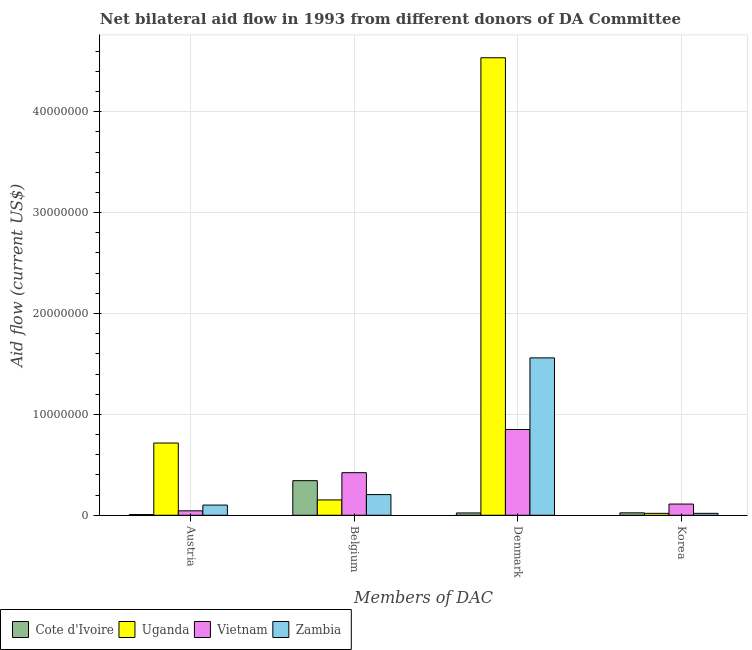How many different coloured bars are there?
Offer a very short reply. 4. Are the number of bars per tick equal to the number of legend labels?
Your answer should be very brief. Yes. How many bars are there on the 1st tick from the right?
Keep it short and to the point. 4. What is the label of the 4th group of bars from the left?
Your answer should be compact. Korea. What is the amount of aid given by denmark in Cote d'Ivoire?
Offer a very short reply. 2.30e+05. Across all countries, what is the maximum amount of aid given by denmark?
Keep it short and to the point. 4.54e+07. Across all countries, what is the minimum amount of aid given by belgium?
Provide a succinct answer. 1.52e+06. In which country was the amount of aid given by austria maximum?
Make the answer very short. Uganda. In which country was the amount of aid given by austria minimum?
Your answer should be compact. Cote d'Ivoire. What is the total amount of aid given by belgium in the graph?
Your answer should be very brief. 1.12e+07. What is the difference between the amount of aid given by korea in Cote d'Ivoire and that in Uganda?
Your response must be concise. 5.00e+04. What is the difference between the amount of aid given by denmark in Cote d'Ivoire and the amount of aid given by belgium in Vietnam?
Make the answer very short. -3.99e+06. What is the average amount of aid given by belgium per country?
Offer a very short reply. 2.80e+06. What is the difference between the amount of aid given by denmark and amount of aid given by korea in Zambia?
Your answer should be very brief. 1.54e+07. In how many countries, is the amount of aid given by austria greater than 14000000 US$?
Ensure brevity in your answer.  0. What is the ratio of the amount of aid given by korea in Cote d'Ivoire to that in Zambia?
Provide a succinct answer. 1.26. What is the difference between the highest and the second highest amount of aid given by austria?
Your response must be concise. 6.15e+06. What is the difference between the highest and the lowest amount of aid given by denmark?
Your answer should be compact. 4.51e+07. In how many countries, is the amount of aid given by austria greater than the average amount of aid given by austria taken over all countries?
Your answer should be very brief. 1. Is it the case that in every country, the sum of the amount of aid given by korea and amount of aid given by austria is greater than the sum of amount of aid given by belgium and amount of aid given by denmark?
Offer a very short reply. No. What does the 2nd bar from the left in Denmark represents?
Make the answer very short. Uganda. What does the 4th bar from the right in Denmark represents?
Keep it short and to the point. Cote d'Ivoire. Are all the bars in the graph horizontal?
Your response must be concise. No. How many countries are there in the graph?
Provide a short and direct response. 4. What is the difference between two consecutive major ticks on the Y-axis?
Keep it short and to the point. 1.00e+07. Does the graph contain grids?
Ensure brevity in your answer.  Yes. How are the legend labels stacked?
Make the answer very short. Horizontal. What is the title of the graph?
Ensure brevity in your answer.  Net bilateral aid flow in 1993 from different donors of DA Committee. What is the label or title of the X-axis?
Give a very brief answer. Members of DAC. What is the Aid flow (current US$) of Uganda in Austria?
Ensure brevity in your answer.  7.16e+06. What is the Aid flow (current US$) of Vietnam in Austria?
Your answer should be compact. 4.40e+05. What is the Aid flow (current US$) in Zambia in Austria?
Ensure brevity in your answer.  1.01e+06. What is the Aid flow (current US$) of Cote d'Ivoire in Belgium?
Make the answer very short. 3.43e+06. What is the Aid flow (current US$) in Uganda in Belgium?
Give a very brief answer. 1.52e+06. What is the Aid flow (current US$) of Vietnam in Belgium?
Provide a short and direct response. 4.22e+06. What is the Aid flow (current US$) in Zambia in Belgium?
Your answer should be compact. 2.05e+06. What is the Aid flow (current US$) in Cote d'Ivoire in Denmark?
Offer a terse response. 2.30e+05. What is the Aid flow (current US$) of Uganda in Denmark?
Offer a very short reply. 4.54e+07. What is the Aid flow (current US$) of Vietnam in Denmark?
Ensure brevity in your answer.  8.50e+06. What is the Aid flow (current US$) of Zambia in Denmark?
Provide a short and direct response. 1.56e+07. What is the Aid flow (current US$) in Cote d'Ivoire in Korea?
Your answer should be compact. 2.40e+05. What is the Aid flow (current US$) of Vietnam in Korea?
Your response must be concise. 1.11e+06. What is the Aid flow (current US$) in Zambia in Korea?
Provide a succinct answer. 1.90e+05. Across all Members of DAC, what is the maximum Aid flow (current US$) in Cote d'Ivoire?
Make the answer very short. 3.43e+06. Across all Members of DAC, what is the maximum Aid flow (current US$) in Uganda?
Make the answer very short. 4.54e+07. Across all Members of DAC, what is the maximum Aid flow (current US$) in Vietnam?
Ensure brevity in your answer.  8.50e+06. Across all Members of DAC, what is the maximum Aid flow (current US$) in Zambia?
Your answer should be compact. 1.56e+07. What is the total Aid flow (current US$) of Cote d'Ivoire in the graph?
Offer a very short reply. 3.97e+06. What is the total Aid flow (current US$) of Uganda in the graph?
Give a very brief answer. 5.42e+07. What is the total Aid flow (current US$) of Vietnam in the graph?
Make the answer very short. 1.43e+07. What is the total Aid flow (current US$) in Zambia in the graph?
Provide a short and direct response. 1.88e+07. What is the difference between the Aid flow (current US$) of Cote d'Ivoire in Austria and that in Belgium?
Ensure brevity in your answer.  -3.36e+06. What is the difference between the Aid flow (current US$) of Uganda in Austria and that in Belgium?
Offer a terse response. 5.64e+06. What is the difference between the Aid flow (current US$) in Vietnam in Austria and that in Belgium?
Keep it short and to the point. -3.78e+06. What is the difference between the Aid flow (current US$) in Zambia in Austria and that in Belgium?
Give a very brief answer. -1.04e+06. What is the difference between the Aid flow (current US$) of Cote d'Ivoire in Austria and that in Denmark?
Your answer should be very brief. -1.60e+05. What is the difference between the Aid flow (current US$) of Uganda in Austria and that in Denmark?
Your answer should be very brief. -3.82e+07. What is the difference between the Aid flow (current US$) of Vietnam in Austria and that in Denmark?
Your answer should be very brief. -8.06e+06. What is the difference between the Aid flow (current US$) in Zambia in Austria and that in Denmark?
Make the answer very short. -1.46e+07. What is the difference between the Aid flow (current US$) of Uganda in Austria and that in Korea?
Your answer should be very brief. 6.97e+06. What is the difference between the Aid flow (current US$) in Vietnam in Austria and that in Korea?
Your response must be concise. -6.70e+05. What is the difference between the Aid flow (current US$) in Zambia in Austria and that in Korea?
Your response must be concise. 8.20e+05. What is the difference between the Aid flow (current US$) of Cote d'Ivoire in Belgium and that in Denmark?
Provide a succinct answer. 3.20e+06. What is the difference between the Aid flow (current US$) of Uganda in Belgium and that in Denmark?
Your answer should be very brief. -4.38e+07. What is the difference between the Aid flow (current US$) of Vietnam in Belgium and that in Denmark?
Offer a terse response. -4.28e+06. What is the difference between the Aid flow (current US$) in Zambia in Belgium and that in Denmark?
Keep it short and to the point. -1.36e+07. What is the difference between the Aid flow (current US$) of Cote d'Ivoire in Belgium and that in Korea?
Your answer should be compact. 3.19e+06. What is the difference between the Aid flow (current US$) of Uganda in Belgium and that in Korea?
Make the answer very short. 1.33e+06. What is the difference between the Aid flow (current US$) of Vietnam in Belgium and that in Korea?
Your answer should be very brief. 3.11e+06. What is the difference between the Aid flow (current US$) in Zambia in Belgium and that in Korea?
Ensure brevity in your answer.  1.86e+06. What is the difference between the Aid flow (current US$) of Cote d'Ivoire in Denmark and that in Korea?
Make the answer very short. -10000. What is the difference between the Aid flow (current US$) in Uganda in Denmark and that in Korea?
Your answer should be very brief. 4.52e+07. What is the difference between the Aid flow (current US$) of Vietnam in Denmark and that in Korea?
Ensure brevity in your answer.  7.39e+06. What is the difference between the Aid flow (current US$) of Zambia in Denmark and that in Korea?
Keep it short and to the point. 1.54e+07. What is the difference between the Aid flow (current US$) in Cote d'Ivoire in Austria and the Aid flow (current US$) in Uganda in Belgium?
Make the answer very short. -1.45e+06. What is the difference between the Aid flow (current US$) in Cote d'Ivoire in Austria and the Aid flow (current US$) in Vietnam in Belgium?
Provide a short and direct response. -4.15e+06. What is the difference between the Aid flow (current US$) in Cote d'Ivoire in Austria and the Aid flow (current US$) in Zambia in Belgium?
Provide a short and direct response. -1.98e+06. What is the difference between the Aid flow (current US$) in Uganda in Austria and the Aid flow (current US$) in Vietnam in Belgium?
Your response must be concise. 2.94e+06. What is the difference between the Aid flow (current US$) in Uganda in Austria and the Aid flow (current US$) in Zambia in Belgium?
Keep it short and to the point. 5.11e+06. What is the difference between the Aid flow (current US$) of Vietnam in Austria and the Aid flow (current US$) of Zambia in Belgium?
Provide a succinct answer. -1.61e+06. What is the difference between the Aid flow (current US$) of Cote d'Ivoire in Austria and the Aid flow (current US$) of Uganda in Denmark?
Make the answer very short. -4.53e+07. What is the difference between the Aid flow (current US$) in Cote d'Ivoire in Austria and the Aid flow (current US$) in Vietnam in Denmark?
Your response must be concise. -8.43e+06. What is the difference between the Aid flow (current US$) in Cote d'Ivoire in Austria and the Aid flow (current US$) in Zambia in Denmark?
Give a very brief answer. -1.55e+07. What is the difference between the Aid flow (current US$) in Uganda in Austria and the Aid flow (current US$) in Vietnam in Denmark?
Make the answer very short. -1.34e+06. What is the difference between the Aid flow (current US$) of Uganda in Austria and the Aid flow (current US$) of Zambia in Denmark?
Keep it short and to the point. -8.44e+06. What is the difference between the Aid flow (current US$) of Vietnam in Austria and the Aid flow (current US$) of Zambia in Denmark?
Make the answer very short. -1.52e+07. What is the difference between the Aid flow (current US$) of Cote d'Ivoire in Austria and the Aid flow (current US$) of Vietnam in Korea?
Provide a succinct answer. -1.04e+06. What is the difference between the Aid flow (current US$) in Cote d'Ivoire in Austria and the Aid flow (current US$) in Zambia in Korea?
Your answer should be very brief. -1.20e+05. What is the difference between the Aid flow (current US$) of Uganda in Austria and the Aid flow (current US$) of Vietnam in Korea?
Make the answer very short. 6.05e+06. What is the difference between the Aid flow (current US$) of Uganda in Austria and the Aid flow (current US$) of Zambia in Korea?
Provide a succinct answer. 6.97e+06. What is the difference between the Aid flow (current US$) of Cote d'Ivoire in Belgium and the Aid flow (current US$) of Uganda in Denmark?
Give a very brief answer. -4.19e+07. What is the difference between the Aid flow (current US$) of Cote d'Ivoire in Belgium and the Aid flow (current US$) of Vietnam in Denmark?
Your answer should be compact. -5.07e+06. What is the difference between the Aid flow (current US$) of Cote d'Ivoire in Belgium and the Aid flow (current US$) of Zambia in Denmark?
Offer a very short reply. -1.22e+07. What is the difference between the Aid flow (current US$) in Uganda in Belgium and the Aid flow (current US$) in Vietnam in Denmark?
Offer a very short reply. -6.98e+06. What is the difference between the Aid flow (current US$) of Uganda in Belgium and the Aid flow (current US$) of Zambia in Denmark?
Give a very brief answer. -1.41e+07. What is the difference between the Aid flow (current US$) in Vietnam in Belgium and the Aid flow (current US$) in Zambia in Denmark?
Provide a short and direct response. -1.14e+07. What is the difference between the Aid flow (current US$) in Cote d'Ivoire in Belgium and the Aid flow (current US$) in Uganda in Korea?
Provide a succinct answer. 3.24e+06. What is the difference between the Aid flow (current US$) in Cote d'Ivoire in Belgium and the Aid flow (current US$) in Vietnam in Korea?
Offer a terse response. 2.32e+06. What is the difference between the Aid flow (current US$) in Cote d'Ivoire in Belgium and the Aid flow (current US$) in Zambia in Korea?
Your answer should be compact. 3.24e+06. What is the difference between the Aid flow (current US$) of Uganda in Belgium and the Aid flow (current US$) of Vietnam in Korea?
Your response must be concise. 4.10e+05. What is the difference between the Aid flow (current US$) in Uganda in Belgium and the Aid flow (current US$) in Zambia in Korea?
Keep it short and to the point. 1.33e+06. What is the difference between the Aid flow (current US$) of Vietnam in Belgium and the Aid flow (current US$) of Zambia in Korea?
Your response must be concise. 4.03e+06. What is the difference between the Aid flow (current US$) in Cote d'Ivoire in Denmark and the Aid flow (current US$) in Uganda in Korea?
Provide a short and direct response. 4.00e+04. What is the difference between the Aid flow (current US$) of Cote d'Ivoire in Denmark and the Aid flow (current US$) of Vietnam in Korea?
Keep it short and to the point. -8.80e+05. What is the difference between the Aid flow (current US$) of Uganda in Denmark and the Aid flow (current US$) of Vietnam in Korea?
Your response must be concise. 4.42e+07. What is the difference between the Aid flow (current US$) of Uganda in Denmark and the Aid flow (current US$) of Zambia in Korea?
Provide a succinct answer. 4.52e+07. What is the difference between the Aid flow (current US$) in Vietnam in Denmark and the Aid flow (current US$) in Zambia in Korea?
Keep it short and to the point. 8.31e+06. What is the average Aid flow (current US$) in Cote d'Ivoire per Members of DAC?
Your answer should be very brief. 9.92e+05. What is the average Aid flow (current US$) of Uganda per Members of DAC?
Make the answer very short. 1.36e+07. What is the average Aid flow (current US$) of Vietnam per Members of DAC?
Your answer should be compact. 3.57e+06. What is the average Aid flow (current US$) in Zambia per Members of DAC?
Give a very brief answer. 4.71e+06. What is the difference between the Aid flow (current US$) in Cote d'Ivoire and Aid flow (current US$) in Uganda in Austria?
Your answer should be very brief. -7.09e+06. What is the difference between the Aid flow (current US$) of Cote d'Ivoire and Aid flow (current US$) of Vietnam in Austria?
Keep it short and to the point. -3.70e+05. What is the difference between the Aid flow (current US$) of Cote d'Ivoire and Aid flow (current US$) of Zambia in Austria?
Offer a terse response. -9.40e+05. What is the difference between the Aid flow (current US$) in Uganda and Aid flow (current US$) in Vietnam in Austria?
Ensure brevity in your answer.  6.72e+06. What is the difference between the Aid flow (current US$) in Uganda and Aid flow (current US$) in Zambia in Austria?
Your answer should be compact. 6.15e+06. What is the difference between the Aid flow (current US$) of Vietnam and Aid flow (current US$) of Zambia in Austria?
Provide a succinct answer. -5.70e+05. What is the difference between the Aid flow (current US$) in Cote d'Ivoire and Aid flow (current US$) in Uganda in Belgium?
Make the answer very short. 1.91e+06. What is the difference between the Aid flow (current US$) of Cote d'Ivoire and Aid flow (current US$) of Vietnam in Belgium?
Your answer should be very brief. -7.90e+05. What is the difference between the Aid flow (current US$) of Cote d'Ivoire and Aid flow (current US$) of Zambia in Belgium?
Offer a terse response. 1.38e+06. What is the difference between the Aid flow (current US$) of Uganda and Aid flow (current US$) of Vietnam in Belgium?
Ensure brevity in your answer.  -2.70e+06. What is the difference between the Aid flow (current US$) in Uganda and Aid flow (current US$) in Zambia in Belgium?
Provide a succinct answer. -5.30e+05. What is the difference between the Aid flow (current US$) in Vietnam and Aid flow (current US$) in Zambia in Belgium?
Offer a terse response. 2.17e+06. What is the difference between the Aid flow (current US$) of Cote d'Ivoire and Aid flow (current US$) of Uganda in Denmark?
Offer a very short reply. -4.51e+07. What is the difference between the Aid flow (current US$) in Cote d'Ivoire and Aid flow (current US$) in Vietnam in Denmark?
Keep it short and to the point. -8.27e+06. What is the difference between the Aid flow (current US$) in Cote d'Ivoire and Aid flow (current US$) in Zambia in Denmark?
Provide a short and direct response. -1.54e+07. What is the difference between the Aid flow (current US$) in Uganda and Aid flow (current US$) in Vietnam in Denmark?
Your answer should be very brief. 3.68e+07. What is the difference between the Aid flow (current US$) of Uganda and Aid flow (current US$) of Zambia in Denmark?
Provide a short and direct response. 2.98e+07. What is the difference between the Aid flow (current US$) of Vietnam and Aid flow (current US$) of Zambia in Denmark?
Provide a succinct answer. -7.10e+06. What is the difference between the Aid flow (current US$) in Cote d'Ivoire and Aid flow (current US$) in Vietnam in Korea?
Make the answer very short. -8.70e+05. What is the difference between the Aid flow (current US$) of Cote d'Ivoire and Aid flow (current US$) of Zambia in Korea?
Offer a terse response. 5.00e+04. What is the difference between the Aid flow (current US$) of Uganda and Aid flow (current US$) of Vietnam in Korea?
Your answer should be compact. -9.20e+05. What is the difference between the Aid flow (current US$) of Uganda and Aid flow (current US$) of Zambia in Korea?
Your response must be concise. 0. What is the difference between the Aid flow (current US$) in Vietnam and Aid flow (current US$) in Zambia in Korea?
Offer a terse response. 9.20e+05. What is the ratio of the Aid flow (current US$) of Cote d'Ivoire in Austria to that in Belgium?
Your answer should be compact. 0.02. What is the ratio of the Aid flow (current US$) in Uganda in Austria to that in Belgium?
Provide a succinct answer. 4.71. What is the ratio of the Aid flow (current US$) of Vietnam in Austria to that in Belgium?
Your answer should be compact. 0.1. What is the ratio of the Aid flow (current US$) in Zambia in Austria to that in Belgium?
Make the answer very short. 0.49. What is the ratio of the Aid flow (current US$) in Cote d'Ivoire in Austria to that in Denmark?
Give a very brief answer. 0.3. What is the ratio of the Aid flow (current US$) of Uganda in Austria to that in Denmark?
Ensure brevity in your answer.  0.16. What is the ratio of the Aid flow (current US$) of Vietnam in Austria to that in Denmark?
Make the answer very short. 0.05. What is the ratio of the Aid flow (current US$) of Zambia in Austria to that in Denmark?
Give a very brief answer. 0.06. What is the ratio of the Aid flow (current US$) in Cote d'Ivoire in Austria to that in Korea?
Ensure brevity in your answer.  0.29. What is the ratio of the Aid flow (current US$) of Uganda in Austria to that in Korea?
Offer a very short reply. 37.68. What is the ratio of the Aid flow (current US$) in Vietnam in Austria to that in Korea?
Your answer should be compact. 0.4. What is the ratio of the Aid flow (current US$) of Zambia in Austria to that in Korea?
Your response must be concise. 5.32. What is the ratio of the Aid flow (current US$) of Cote d'Ivoire in Belgium to that in Denmark?
Provide a short and direct response. 14.91. What is the ratio of the Aid flow (current US$) of Uganda in Belgium to that in Denmark?
Offer a very short reply. 0.03. What is the ratio of the Aid flow (current US$) in Vietnam in Belgium to that in Denmark?
Provide a short and direct response. 0.5. What is the ratio of the Aid flow (current US$) of Zambia in Belgium to that in Denmark?
Provide a short and direct response. 0.13. What is the ratio of the Aid flow (current US$) in Cote d'Ivoire in Belgium to that in Korea?
Offer a terse response. 14.29. What is the ratio of the Aid flow (current US$) in Uganda in Belgium to that in Korea?
Your answer should be compact. 8. What is the ratio of the Aid flow (current US$) in Vietnam in Belgium to that in Korea?
Your answer should be very brief. 3.8. What is the ratio of the Aid flow (current US$) of Zambia in Belgium to that in Korea?
Give a very brief answer. 10.79. What is the ratio of the Aid flow (current US$) of Cote d'Ivoire in Denmark to that in Korea?
Provide a short and direct response. 0.96. What is the ratio of the Aid flow (current US$) of Uganda in Denmark to that in Korea?
Make the answer very short. 238.68. What is the ratio of the Aid flow (current US$) in Vietnam in Denmark to that in Korea?
Make the answer very short. 7.66. What is the ratio of the Aid flow (current US$) in Zambia in Denmark to that in Korea?
Keep it short and to the point. 82.11. What is the difference between the highest and the second highest Aid flow (current US$) of Cote d'Ivoire?
Your answer should be very brief. 3.19e+06. What is the difference between the highest and the second highest Aid flow (current US$) in Uganda?
Keep it short and to the point. 3.82e+07. What is the difference between the highest and the second highest Aid flow (current US$) of Vietnam?
Ensure brevity in your answer.  4.28e+06. What is the difference between the highest and the second highest Aid flow (current US$) in Zambia?
Offer a terse response. 1.36e+07. What is the difference between the highest and the lowest Aid flow (current US$) of Cote d'Ivoire?
Your answer should be compact. 3.36e+06. What is the difference between the highest and the lowest Aid flow (current US$) in Uganda?
Offer a very short reply. 4.52e+07. What is the difference between the highest and the lowest Aid flow (current US$) in Vietnam?
Provide a succinct answer. 8.06e+06. What is the difference between the highest and the lowest Aid flow (current US$) of Zambia?
Ensure brevity in your answer.  1.54e+07. 